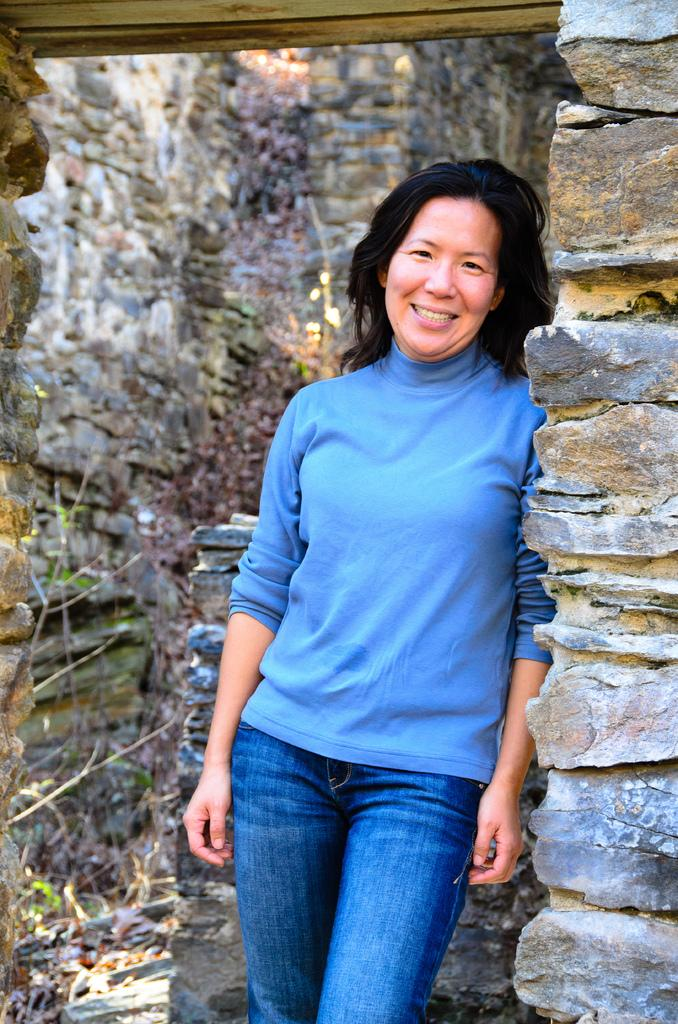Who is present in the image? There is a woman in the image. What expression does the woman have? The woman is smiling. What can be seen in the background of the image? There is a wall in the background of the image. What type of crown is the woman wearing in the image? There is no crown present in the image; the woman is not wearing any headwear. 